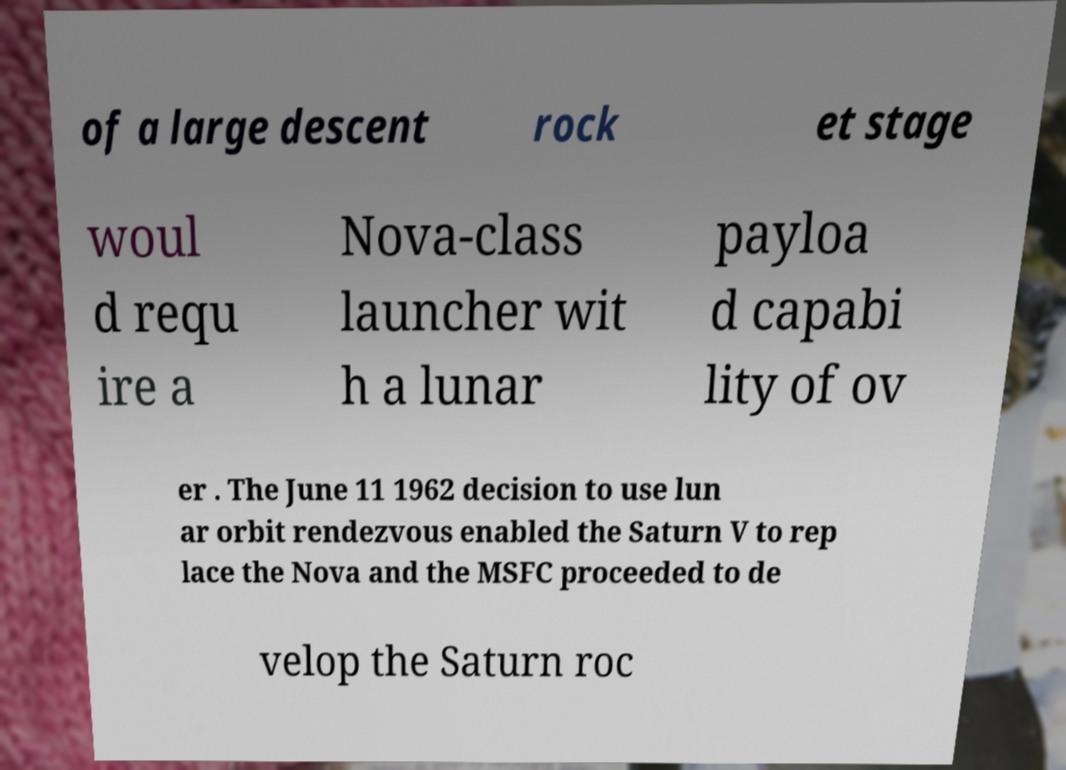For documentation purposes, I need the text within this image transcribed. Could you provide that? of a large descent rock et stage woul d requ ire a Nova-class launcher wit h a lunar payloa d capabi lity of ov er . The June 11 1962 decision to use lun ar orbit rendezvous enabled the Saturn V to rep lace the Nova and the MSFC proceeded to de velop the Saturn roc 